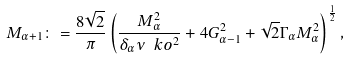Convert formula to latex. <formula><loc_0><loc_0><loc_500><loc_500>M _ { \alpha + 1 } \colon = \frac { 8 \sqrt { 2 } } { \pi } \left ( \frac { M ^ { 2 } _ { \alpha } } { \delta _ { \alpha } \nu \ k o ^ { 2 } } + 4 G ^ { 2 } _ { \alpha - 1 } + \sqrt { 2 } \Gamma _ { \alpha } M ^ { 2 } _ { \alpha } \right ) ^ { \frac { 1 } { 2 } } ,</formula> 